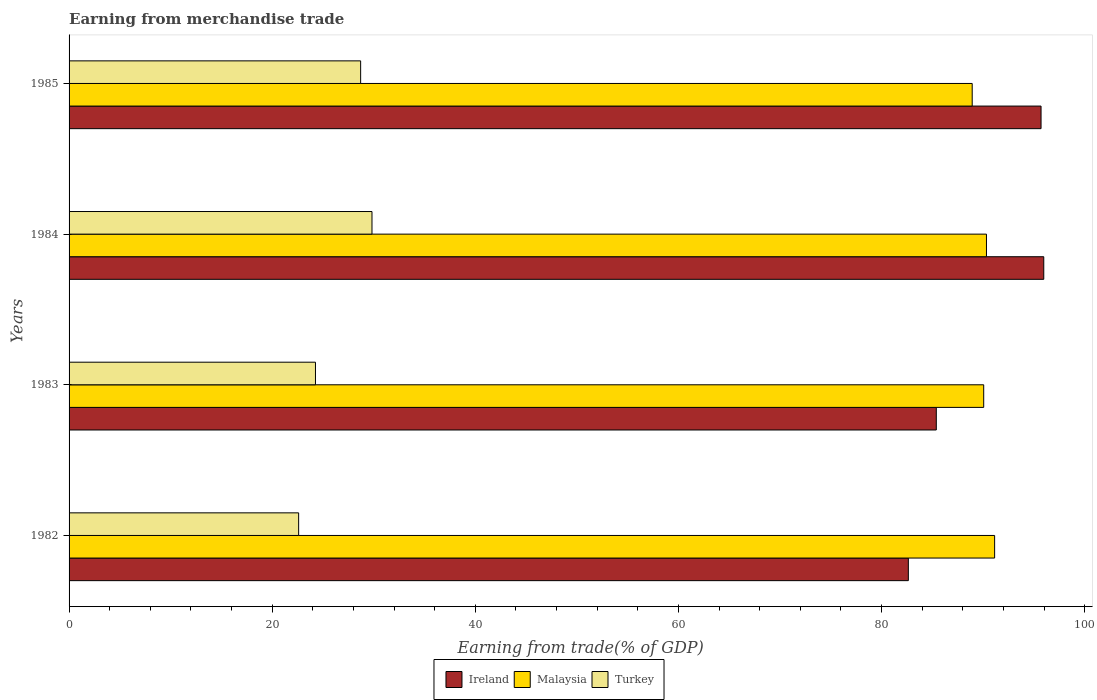Are the number of bars on each tick of the Y-axis equal?
Your answer should be compact. Yes. How many bars are there on the 3rd tick from the bottom?
Give a very brief answer. 3. What is the label of the 4th group of bars from the top?
Offer a very short reply. 1982. What is the earnings from trade in Malaysia in 1983?
Ensure brevity in your answer.  90.05. Across all years, what is the maximum earnings from trade in Ireland?
Your answer should be compact. 95.96. Across all years, what is the minimum earnings from trade in Turkey?
Your answer should be very brief. 22.6. In which year was the earnings from trade in Turkey maximum?
Your answer should be very brief. 1984. What is the total earnings from trade in Malaysia in the graph?
Provide a short and direct response. 360.42. What is the difference between the earnings from trade in Malaysia in 1982 and that in 1983?
Give a very brief answer. 1.07. What is the difference between the earnings from trade in Malaysia in 1985 and the earnings from trade in Ireland in 1983?
Provide a short and direct response. 3.53. What is the average earnings from trade in Malaysia per year?
Make the answer very short. 90.11. In the year 1985, what is the difference between the earnings from trade in Malaysia and earnings from trade in Turkey?
Your answer should be very brief. 60.21. What is the ratio of the earnings from trade in Ireland in 1983 to that in 1984?
Offer a very short reply. 0.89. Is the earnings from trade in Malaysia in 1982 less than that in 1984?
Give a very brief answer. No. Is the difference between the earnings from trade in Malaysia in 1982 and 1983 greater than the difference between the earnings from trade in Turkey in 1982 and 1983?
Make the answer very short. Yes. What is the difference between the highest and the second highest earnings from trade in Ireland?
Your response must be concise. 0.27. What is the difference between the highest and the lowest earnings from trade in Turkey?
Provide a short and direct response. 7.22. In how many years, is the earnings from trade in Ireland greater than the average earnings from trade in Ireland taken over all years?
Give a very brief answer. 2. What does the 1st bar from the top in 1985 represents?
Your answer should be very brief. Turkey. Are all the bars in the graph horizontal?
Ensure brevity in your answer.  Yes. How many years are there in the graph?
Keep it short and to the point. 4. Are the values on the major ticks of X-axis written in scientific E-notation?
Offer a terse response. No. Does the graph contain any zero values?
Your answer should be very brief. No. Where does the legend appear in the graph?
Ensure brevity in your answer.  Bottom center. How many legend labels are there?
Provide a succinct answer. 3. What is the title of the graph?
Keep it short and to the point. Earning from merchandise trade. Does "Fragile and conflict affected situations" appear as one of the legend labels in the graph?
Provide a short and direct response. No. What is the label or title of the X-axis?
Your answer should be very brief. Earning from trade(% of GDP). What is the Earning from trade(% of GDP) of Ireland in 1982?
Ensure brevity in your answer.  82.63. What is the Earning from trade(% of GDP) in Malaysia in 1982?
Your answer should be compact. 91.13. What is the Earning from trade(% of GDP) of Turkey in 1982?
Give a very brief answer. 22.6. What is the Earning from trade(% of GDP) of Ireland in 1983?
Your response must be concise. 85.38. What is the Earning from trade(% of GDP) in Malaysia in 1983?
Provide a short and direct response. 90.05. What is the Earning from trade(% of GDP) of Turkey in 1983?
Your answer should be compact. 24.26. What is the Earning from trade(% of GDP) of Ireland in 1984?
Provide a short and direct response. 95.96. What is the Earning from trade(% of GDP) in Malaysia in 1984?
Offer a terse response. 90.32. What is the Earning from trade(% of GDP) in Turkey in 1984?
Offer a terse response. 29.82. What is the Earning from trade(% of GDP) of Ireland in 1985?
Offer a very short reply. 95.7. What is the Earning from trade(% of GDP) of Malaysia in 1985?
Make the answer very short. 88.92. What is the Earning from trade(% of GDP) of Turkey in 1985?
Your answer should be very brief. 28.71. Across all years, what is the maximum Earning from trade(% of GDP) in Ireland?
Make the answer very short. 95.96. Across all years, what is the maximum Earning from trade(% of GDP) in Malaysia?
Offer a terse response. 91.13. Across all years, what is the maximum Earning from trade(% of GDP) of Turkey?
Ensure brevity in your answer.  29.82. Across all years, what is the minimum Earning from trade(% of GDP) of Ireland?
Offer a very short reply. 82.63. Across all years, what is the minimum Earning from trade(% of GDP) in Malaysia?
Your answer should be compact. 88.92. Across all years, what is the minimum Earning from trade(% of GDP) of Turkey?
Keep it short and to the point. 22.6. What is the total Earning from trade(% of GDP) of Ireland in the graph?
Provide a succinct answer. 359.68. What is the total Earning from trade(% of GDP) of Malaysia in the graph?
Your answer should be very brief. 360.42. What is the total Earning from trade(% of GDP) in Turkey in the graph?
Offer a terse response. 105.39. What is the difference between the Earning from trade(% of GDP) in Ireland in 1982 and that in 1983?
Make the answer very short. -2.75. What is the difference between the Earning from trade(% of GDP) in Malaysia in 1982 and that in 1983?
Offer a very short reply. 1.07. What is the difference between the Earning from trade(% of GDP) in Turkey in 1982 and that in 1983?
Ensure brevity in your answer.  -1.66. What is the difference between the Earning from trade(% of GDP) of Ireland in 1982 and that in 1984?
Give a very brief answer. -13.33. What is the difference between the Earning from trade(% of GDP) in Malaysia in 1982 and that in 1984?
Your answer should be compact. 0.8. What is the difference between the Earning from trade(% of GDP) of Turkey in 1982 and that in 1984?
Give a very brief answer. -7.22. What is the difference between the Earning from trade(% of GDP) of Ireland in 1982 and that in 1985?
Your answer should be very brief. -13.07. What is the difference between the Earning from trade(% of GDP) in Malaysia in 1982 and that in 1985?
Your answer should be compact. 2.21. What is the difference between the Earning from trade(% of GDP) in Turkey in 1982 and that in 1985?
Your answer should be compact. -6.1. What is the difference between the Earning from trade(% of GDP) of Ireland in 1983 and that in 1984?
Keep it short and to the point. -10.58. What is the difference between the Earning from trade(% of GDP) of Malaysia in 1983 and that in 1984?
Make the answer very short. -0.27. What is the difference between the Earning from trade(% of GDP) in Turkey in 1983 and that in 1984?
Keep it short and to the point. -5.56. What is the difference between the Earning from trade(% of GDP) of Ireland in 1983 and that in 1985?
Ensure brevity in your answer.  -10.31. What is the difference between the Earning from trade(% of GDP) of Malaysia in 1983 and that in 1985?
Provide a short and direct response. 1.13. What is the difference between the Earning from trade(% of GDP) in Turkey in 1983 and that in 1985?
Provide a short and direct response. -4.45. What is the difference between the Earning from trade(% of GDP) of Ireland in 1984 and that in 1985?
Make the answer very short. 0.27. What is the difference between the Earning from trade(% of GDP) of Malaysia in 1984 and that in 1985?
Offer a terse response. 1.4. What is the difference between the Earning from trade(% of GDP) of Turkey in 1984 and that in 1985?
Keep it short and to the point. 1.12. What is the difference between the Earning from trade(% of GDP) in Ireland in 1982 and the Earning from trade(% of GDP) in Malaysia in 1983?
Keep it short and to the point. -7.42. What is the difference between the Earning from trade(% of GDP) in Ireland in 1982 and the Earning from trade(% of GDP) in Turkey in 1983?
Offer a very short reply. 58.37. What is the difference between the Earning from trade(% of GDP) in Malaysia in 1982 and the Earning from trade(% of GDP) in Turkey in 1983?
Offer a terse response. 66.87. What is the difference between the Earning from trade(% of GDP) of Ireland in 1982 and the Earning from trade(% of GDP) of Malaysia in 1984?
Make the answer very short. -7.69. What is the difference between the Earning from trade(% of GDP) of Ireland in 1982 and the Earning from trade(% of GDP) of Turkey in 1984?
Provide a succinct answer. 52.81. What is the difference between the Earning from trade(% of GDP) of Malaysia in 1982 and the Earning from trade(% of GDP) of Turkey in 1984?
Your answer should be compact. 61.3. What is the difference between the Earning from trade(% of GDP) of Ireland in 1982 and the Earning from trade(% of GDP) of Malaysia in 1985?
Provide a succinct answer. -6.29. What is the difference between the Earning from trade(% of GDP) of Ireland in 1982 and the Earning from trade(% of GDP) of Turkey in 1985?
Keep it short and to the point. 53.93. What is the difference between the Earning from trade(% of GDP) of Malaysia in 1982 and the Earning from trade(% of GDP) of Turkey in 1985?
Make the answer very short. 62.42. What is the difference between the Earning from trade(% of GDP) in Ireland in 1983 and the Earning from trade(% of GDP) in Malaysia in 1984?
Your response must be concise. -4.94. What is the difference between the Earning from trade(% of GDP) in Ireland in 1983 and the Earning from trade(% of GDP) in Turkey in 1984?
Give a very brief answer. 55.56. What is the difference between the Earning from trade(% of GDP) of Malaysia in 1983 and the Earning from trade(% of GDP) of Turkey in 1984?
Your answer should be very brief. 60.23. What is the difference between the Earning from trade(% of GDP) in Ireland in 1983 and the Earning from trade(% of GDP) in Malaysia in 1985?
Keep it short and to the point. -3.53. What is the difference between the Earning from trade(% of GDP) in Ireland in 1983 and the Earning from trade(% of GDP) in Turkey in 1985?
Provide a short and direct response. 56.68. What is the difference between the Earning from trade(% of GDP) in Malaysia in 1983 and the Earning from trade(% of GDP) in Turkey in 1985?
Offer a very short reply. 61.35. What is the difference between the Earning from trade(% of GDP) in Ireland in 1984 and the Earning from trade(% of GDP) in Malaysia in 1985?
Offer a terse response. 7.05. What is the difference between the Earning from trade(% of GDP) of Ireland in 1984 and the Earning from trade(% of GDP) of Turkey in 1985?
Your answer should be very brief. 67.26. What is the difference between the Earning from trade(% of GDP) in Malaysia in 1984 and the Earning from trade(% of GDP) in Turkey in 1985?
Make the answer very short. 61.62. What is the average Earning from trade(% of GDP) in Ireland per year?
Keep it short and to the point. 89.92. What is the average Earning from trade(% of GDP) of Malaysia per year?
Provide a succinct answer. 90.11. What is the average Earning from trade(% of GDP) in Turkey per year?
Your answer should be compact. 26.35. In the year 1982, what is the difference between the Earning from trade(% of GDP) of Ireland and Earning from trade(% of GDP) of Malaysia?
Your response must be concise. -8.49. In the year 1982, what is the difference between the Earning from trade(% of GDP) in Ireland and Earning from trade(% of GDP) in Turkey?
Your response must be concise. 60.03. In the year 1982, what is the difference between the Earning from trade(% of GDP) of Malaysia and Earning from trade(% of GDP) of Turkey?
Your answer should be compact. 68.52. In the year 1983, what is the difference between the Earning from trade(% of GDP) in Ireland and Earning from trade(% of GDP) in Malaysia?
Your answer should be very brief. -4.67. In the year 1983, what is the difference between the Earning from trade(% of GDP) in Ireland and Earning from trade(% of GDP) in Turkey?
Provide a short and direct response. 61.13. In the year 1983, what is the difference between the Earning from trade(% of GDP) of Malaysia and Earning from trade(% of GDP) of Turkey?
Provide a short and direct response. 65.79. In the year 1984, what is the difference between the Earning from trade(% of GDP) of Ireland and Earning from trade(% of GDP) of Malaysia?
Make the answer very short. 5.64. In the year 1984, what is the difference between the Earning from trade(% of GDP) in Ireland and Earning from trade(% of GDP) in Turkey?
Ensure brevity in your answer.  66.14. In the year 1984, what is the difference between the Earning from trade(% of GDP) in Malaysia and Earning from trade(% of GDP) in Turkey?
Ensure brevity in your answer.  60.5. In the year 1985, what is the difference between the Earning from trade(% of GDP) of Ireland and Earning from trade(% of GDP) of Malaysia?
Your answer should be compact. 6.78. In the year 1985, what is the difference between the Earning from trade(% of GDP) in Ireland and Earning from trade(% of GDP) in Turkey?
Keep it short and to the point. 66.99. In the year 1985, what is the difference between the Earning from trade(% of GDP) of Malaysia and Earning from trade(% of GDP) of Turkey?
Make the answer very short. 60.21. What is the ratio of the Earning from trade(% of GDP) in Ireland in 1982 to that in 1983?
Make the answer very short. 0.97. What is the ratio of the Earning from trade(% of GDP) of Malaysia in 1982 to that in 1983?
Your answer should be very brief. 1.01. What is the ratio of the Earning from trade(% of GDP) in Turkey in 1982 to that in 1983?
Your answer should be very brief. 0.93. What is the ratio of the Earning from trade(% of GDP) of Ireland in 1982 to that in 1984?
Your response must be concise. 0.86. What is the ratio of the Earning from trade(% of GDP) in Malaysia in 1982 to that in 1984?
Your answer should be compact. 1.01. What is the ratio of the Earning from trade(% of GDP) in Turkey in 1982 to that in 1984?
Your answer should be very brief. 0.76. What is the ratio of the Earning from trade(% of GDP) of Ireland in 1982 to that in 1985?
Offer a terse response. 0.86. What is the ratio of the Earning from trade(% of GDP) of Malaysia in 1982 to that in 1985?
Provide a succinct answer. 1.02. What is the ratio of the Earning from trade(% of GDP) in Turkey in 1982 to that in 1985?
Offer a terse response. 0.79. What is the ratio of the Earning from trade(% of GDP) of Ireland in 1983 to that in 1984?
Offer a terse response. 0.89. What is the ratio of the Earning from trade(% of GDP) of Turkey in 1983 to that in 1984?
Your response must be concise. 0.81. What is the ratio of the Earning from trade(% of GDP) of Ireland in 1983 to that in 1985?
Your answer should be compact. 0.89. What is the ratio of the Earning from trade(% of GDP) of Malaysia in 1983 to that in 1985?
Offer a terse response. 1.01. What is the ratio of the Earning from trade(% of GDP) of Turkey in 1983 to that in 1985?
Ensure brevity in your answer.  0.85. What is the ratio of the Earning from trade(% of GDP) of Ireland in 1984 to that in 1985?
Provide a succinct answer. 1. What is the ratio of the Earning from trade(% of GDP) in Malaysia in 1984 to that in 1985?
Ensure brevity in your answer.  1.02. What is the ratio of the Earning from trade(% of GDP) of Turkey in 1984 to that in 1985?
Provide a short and direct response. 1.04. What is the difference between the highest and the second highest Earning from trade(% of GDP) in Ireland?
Your answer should be very brief. 0.27. What is the difference between the highest and the second highest Earning from trade(% of GDP) in Malaysia?
Your answer should be compact. 0.8. What is the difference between the highest and the second highest Earning from trade(% of GDP) of Turkey?
Provide a short and direct response. 1.12. What is the difference between the highest and the lowest Earning from trade(% of GDP) of Ireland?
Make the answer very short. 13.33. What is the difference between the highest and the lowest Earning from trade(% of GDP) in Malaysia?
Your response must be concise. 2.21. What is the difference between the highest and the lowest Earning from trade(% of GDP) of Turkey?
Provide a succinct answer. 7.22. 